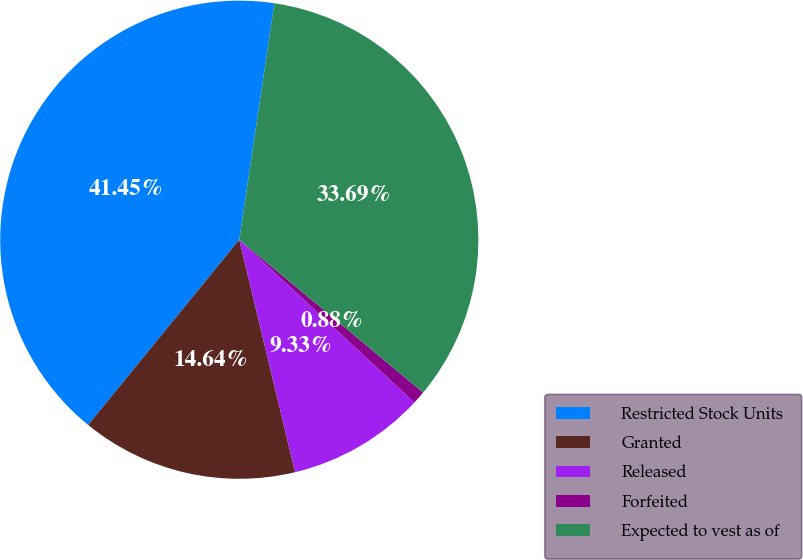Convert chart to OTSL. <chart><loc_0><loc_0><loc_500><loc_500><pie_chart><fcel>Restricted Stock Units<fcel>Granted<fcel>Released<fcel>Forfeited<fcel>Expected to vest as of<nl><fcel>41.45%<fcel>14.64%<fcel>9.33%<fcel>0.88%<fcel>33.69%<nl></chart> 